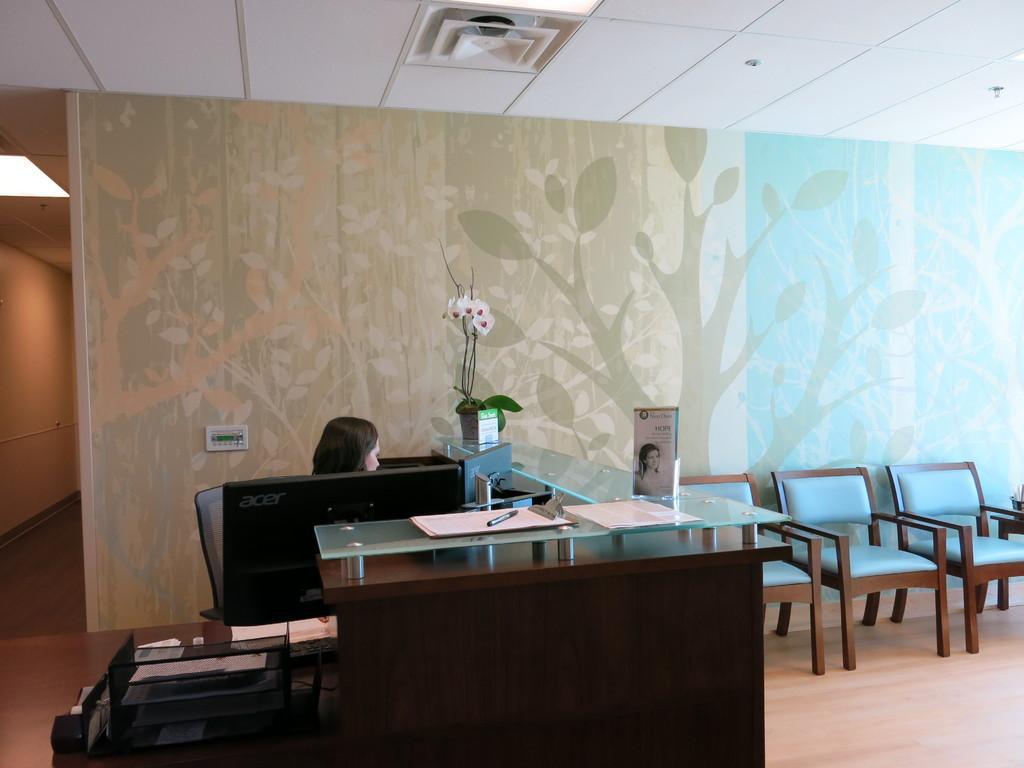In one or two sentences, can you explain what this image depicts? This image is clicked in a room. There is a woman sitting in a chair, in front of a computer. To the right, there are chairs. In the background, there is a wallpaper on the wall. At the top, there is a roof. 